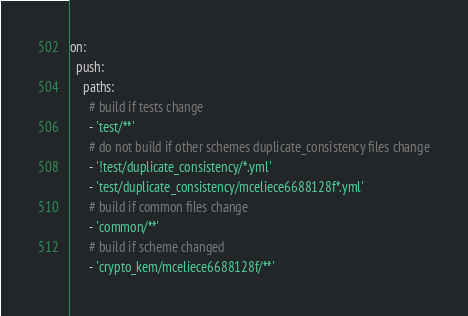Convert code to text. <code><loc_0><loc_0><loc_500><loc_500><_YAML_>on:
  push:
    paths:
      # build if tests change
      - 'test/**'
      # do not build if other schemes duplicate_consistency files change
      - '!test/duplicate_consistency/*.yml'
      - 'test/duplicate_consistency/mceliece6688128f*.yml'
      # build if common files change
      - 'common/**'
      # build if scheme changed
      - 'crypto_kem/mceliece6688128f/**'</code> 